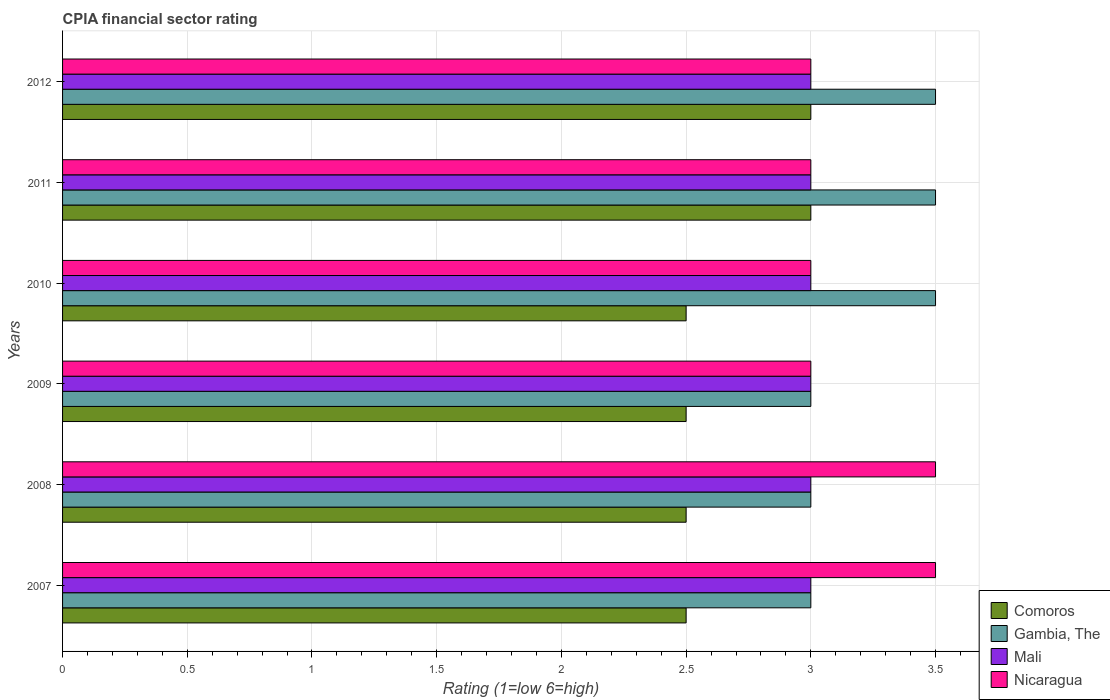How many different coloured bars are there?
Your response must be concise. 4. How many groups of bars are there?
Your answer should be very brief. 6. How many bars are there on the 1st tick from the top?
Provide a short and direct response. 4. In how many cases, is the number of bars for a given year not equal to the number of legend labels?
Provide a succinct answer. 0. Across all years, what is the maximum CPIA rating in Mali?
Ensure brevity in your answer.  3. Across all years, what is the minimum CPIA rating in Comoros?
Make the answer very short. 2.5. In which year was the CPIA rating in Gambia, The minimum?
Give a very brief answer. 2007. What is the total CPIA rating in Comoros in the graph?
Ensure brevity in your answer.  16. What is the difference between the CPIA rating in Nicaragua in 2009 and that in 2010?
Make the answer very short. 0. What is the difference between the CPIA rating in Comoros in 2009 and the CPIA rating in Nicaragua in 2008?
Your answer should be very brief. -1. What is the average CPIA rating in Gambia, The per year?
Offer a terse response. 3.25. What is the ratio of the CPIA rating in Mali in 2009 to that in 2012?
Keep it short and to the point. 1. Is the CPIA rating in Nicaragua in 2008 less than that in 2010?
Offer a very short reply. No. What is the difference between the highest and the lowest CPIA rating in Comoros?
Offer a very short reply. 0.5. In how many years, is the CPIA rating in Gambia, The greater than the average CPIA rating in Gambia, The taken over all years?
Ensure brevity in your answer.  3. What does the 2nd bar from the top in 2010 represents?
Make the answer very short. Mali. What does the 2nd bar from the bottom in 2007 represents?
Your response must be concise. Gambia, The. Is it the case that in every year, the sum of the CPIA rating in Gambia, The and CPIA rating in Mali is greater than the CPIA rating in Comoros?
Your answer should be compact. Yes. How many bars are there?
Ensure brevity in your answer.  24. How many years are there in the graph?
Provide a short and direct response. 6. How are the legend labels stacked?
Make the answer very short. Vertical. What is the title of the graph?
Make the answer very short. CPIA financial sector rating. What is the Rating (1=low 6=high) of Gambia, The in 2007?
Keep it short and to the point. 3. What is the Rating (1=low 6=high) of Comoros in 2008?
Your answer should be very brief. 2.5. What is the Rating (1=low 6=high) in Gambia, The in 2008?
Give a very brief answer. 3. What is the Rating (1=low 6=high) of Comoros in 2009?
Provide a short and direct response. 2.5. What is the Rating (1=low 6=high) in Comoros in 2010?
Your response must be concise. 2.5. What is the Rating (1=low 6=high) of Mali in 2010?
Ensure brevity in your answer.  3. What is the Rating (1=low 6=high) of Gambia, The in 2011?
Keep it short and to the point. 3.5. What is the Rating (1=low 6=high) in Mali in 2011?
Your answer should be very brief. 3. What is the Rating (1=low 6=high) in Nicaragua in 2011?
Offer a very short reply. 3. What is the Rating (1=low 6=high) in Gambia, The in 2012?
Give a very brief answer. 3.5. Across all years, what is the maximum Rating (1=low 6=high) of Mali?
Keep it short and to the point. 3. Across all years, what is the minimum Rating (1=low 6=high) of Comoros?
Make the answer very short. 2.5. Across all years, what is the minimum Rating (1=low 6=high) of Gambia, The?
Offer a very short reply. 3. What is the total Rating (1=low 6=high) of Comoros in the graph?
Make the answer very short. 16. What is the total Rating (1=low 6=high) in Mali in the graph?
Offer a very short reply. 18. What is the difference between the Rating (1=low 6=high) of Mali in 2007 and that in 2008?
Make the answer very short. 0. What is the difference between the Rating (1=low 6=high) in Comoros in 2007 and that in 2009?
Provide a short and direct response. 0. What is the difference between the Rating (1=low 6=high) in Gambia, The in 2007 and that in 2011?
Give a very brief answer. -0.5. What is the difference between the Rating (1=low 6=high) of Comoros in 2007 and that in 2012?
Keep it short and to the point. -0.5. What is the difference between the Rating (1=low 6=high) of Mali in 2007 and that in 2012?
Make the answer very short. 0. What is the difference between the Rating (1=low 6=high) of Nicaragua in 2007 and that in 2012?
Your answer should be compact. 0.5. What is the difference between the Rating (1=low 6=high) of Comoros in 2008 and that in 2009?
Provide a short and direct response. 0. What is the difference between the Rating (1=low 6=high) of Mali in 2008 and that in 2010?
Offer a very short reply. 0. What is the difference between the Rating (1=low 6=high) of Nicaragua in 2008 and that in 2010?
Your answer should be very brief. 0.5. What is the difference between the Rating (1=low 6=high) of Nicaragua in 2008 and that in 2011?
Offer a very short reply. 0.5. What is the difference between the Rating (1=low 6=high) in Comoros in 2008 and that in 2012?
Provide a succinct answer. -0.5. What is the difference between the Rating (1=low 6=high) of Mali in 2008 and that in 2012?
Offer a very short reply. 0. What is the difference between the Rating (1=low 6=high) in Nicaragua in 2008 and that in 2012?
Your answer should be very brief. 0.5. What is the difference between the Rating (1=low 6=high) of Nicaragua in 2009 and that in 2010?
Offer a very short reply. 0. What is the difference between the Rating (1=low 6=high) in Mali in 2009 and that in 2012?
Your answer should be very brief. 0. What is the difference between the Rating (1=low 6=high) of Nicaragua in 2009 and that in 2012?
Offer a very short reply. 0. What is the difference between the Rating (1=low 6=high) of Comoros in 2010 and that in 2011?
Your response must be concise. -0.5. What is the difference between the Rating (1=low 6=high) of Comoros in 2010 and that in 2012?
Ensure brevity in your answer.  -0.5. What is the difference between the Rating (1=low 6=high) in Mali in 2010 and that in 2012?
Ensure brevity in your answer.  0. What is the difference between the Rating (1=low 6=high) of Nicaragua in 2010 and that in 2012?
Provide a short and direct response. 0. What is the difference between the Rating (1=low 6=high) of Gambia, The in 2011 and that in 2012?
Ensure brevity in your answer.  0. What is the difference between the Rating (1=low 6=high) in Mali in 2011 and that in 2012?
Give a very brief answer. 0. What is the difference between the Rating (1=low 6=high) of Comoros in 2007 and the Rating (1=low 6=high) of Mali in 2008?
Your answer should be very brief. -0.5. What is the difference between the Rating (1=low 6=high) in Gambia, The in 2007 and the Rating (1=low 6=high) in Mali in 2008?
Your answer should be very brief. 0. What is the difference between the Rating (1=low 6=high) of Gambia, The in 2007 and the Rating (1=low 6=high) of Nicaragua in 2008?
Your answer should be very brief. -0.5. What is the difference between the Rating (1=low 6=high) in Comoros in 2007 and the Rating (1=low 6=high) in Gambia, The in 2009?
Ensure brevity in your answer.  -0.5. What is the difference between the Rating (1=low 6=high) of Comoros in 2007 and the Rating (1=low 6=high) of Mali in 2009?
Offer a terse response. -0.5. What is the difference between the Rating (1=low 6=high) of Gambia, The in 2007 and the Rating (1=low 6=high) of Mali in 2010?
Your response must be concise. 0. What is the difference between the Rating (1=low 6=high) in Comoros in 2007 and the Rating (1=low 6=high) in Nicaragua in 2011?
Keep it short and to the point. -0.5. What is the difference between the Rating (1=low 6=high) of Gambia, The in 2007 and the Rating (1=low 6=high) of Nicaragua in 2011?
Your answer should be very brief. 0. What is the difference between the Rating (1=low 6=high) in Comoros in 2007 and the Rating (1=low 6=high) in Gambia, The in 2012?
Your answer should be compact. -1. What is the difference between the Rating (1=low 6=high) of Comoros in 2007 and the Rating (1=low 6=high) of Mali in 2012?
Provide a succinct answer. -0.5. What is the difference between the Rating (1=low 6=high) of Mali in 2007 and the Rating (1=low 6=high) of Nicaragua in 2012?
Provide a short and direct response. 0. What is the difference between the Rating (1=low 6=high) of Gambia, The in 2008 and the Rating (1=low 6=high) of Mali in 2009?
Make the answer very short. 0. What is the difference between the Rating (1=low 6=high) of Gambia, The in 2008 and the Rating (1=low 6=high) of Nicaragua in 2009?
Give a very brief answer. 0. What is the difference between the Rating (1=low 6=high) in Comoros in 2008 and the Rating (1=low 6=high) in Gambia, The in 2010?
Your response must be concise. -1. What is the difference between the Rating (1=low 6=high) of Comoros in 2008 and the Rating (1=low 6=high) of Mali in 2010?
Your response must be concise. -0.5. What is the difference between the Rating (1=low 6=high) in Gambia, The in 2008 and the Rating (1=low 6=high) in Nicaragua in 2010?
Your response must be concise. 0. What is the difference between the Rating (1=low 6=high) of Mali in 2008 and the Rating (1=low 6=high) of Nicaragua in 2010?
Offer a terse response. 0. What is the difference between the Rating (1=low 6=high) in Comoros in 2008 and the Rating (1=low 6=high) in Mali in 2011?
Give a very brief answer. -0.5. What is the difference between the Rating (1=low 6=high) in Comoros in 2008 and the Rating (1=low 6=high) in Nicaragua in 2011?
Give a very brief answer. -0.5. What is the difference between the Rating (1=low 6=high) of Comoros in 2008 and the Rating (1=low 6=high) of Gambia, The in 2012?
Provide a succinct answer. -1. What is the difference between the Rating (1=low 6=high) in Mali in 2008 and the Rating (1=low 6=high) in Nicaragua in 2012?
Keep it short and to the point. 0. What is the difference between the Rating (1=low 6=high) in Comoros in 2009 and the Rating (1=low 6=high) in Gambia, The in 2010?
Provide a succinct answer. -1. What is the difference between the Rating (1=low 6=high) in Comoros in 2009 and the Rating (1=low 6=high) in Mali in 2010?
Ensure brevity in your answer.  -0.5. What is the difference between the Rating (1=low 6=high) in Comoros in 2009 and the Rating (1=low 6=high) in Nicaragua in 2010?
Keep it short and to the point. -0.5. What is the difference between the Rating (1=low 6=high) in Gambia, The in 2009 and the Rating (1=low 6=high) in Mali in 2010?
Provide a succinct answer. 0. What is the difference between the Rating (1=low 6=high) in Mali in 2009 and the Rating (1=low 6=high) in Nicaragua in 2010?
Your answer should be compact. 0. What is the difference between the Rating (1=low 6=high) of Comoros in 2009 and the Rating (1=low 6=high) of Mali in 2011?
Make the answer very short. -0.5. What is the difference between the Rating (1=low 6=high) of Gambia, The in 2009 and the Rating (1=low 6=high) of Mali in 2011?
Provide a succinct answer. 0. What is the difference between the Rating (1=low 6=high) of Comoros in 2009 and the Rating (1=low 6=high) of Gambia, The in 2012?
Ensure brevity in your answer.  -1. What is the difference between the Rating (1=low 6=high) of Comoros in 2009 and the Rating (1=low 6=high) of Nicaragua in 2012?
Offer a very short reply. -0.5. What is the difference between the Rating (1=low 6=high) of Gambia, The in 2009 and the Rating (1=low 6=high) of Mali in 2012?
Keep it short and to the point. 0. What is the difference between the Rating (1=low 6=high) of Mali in 2009 and the Rating (1=low 6=high) of Nicaragua in 2012?
Provide a short and direct response. 0. What is the difference between the Rating (1=low 6=high) in Comoros in 2010 and the Rating (1=low 6=high) in Gambia, The in 2011?
Keep it short and to the point. -1. What is the difference between the Rating (1=low 6=high) of Comoros in 2010 and the Rating (1=low 6=high) of Mali in 2011?
Provide a short and direct response. -0.5. What is the difference between the Rating (1=low 6=high) of Comoros in 2010 and the Rating (1=low 6=high) of Nicaragua in 2011?
Give a very brief answer. -0.5. What is the difference between the Rating (1=low 6=high) in Gambia, The in 2010 and the Rating (1=low 6=high) in Mali in 2011?
Your answer should be very brief. 0.5. What is the difference between the Rating (1=low 6=high) in Gambia, The in 2010 and the Rating (1=low 6=high) in Nicaragua in 2011?
Provide a succinct answer. 0.5. What is the difference between the Rating (1=low 6=high) in Comoros in 2010 and the Rating (1=low 6=high) in Mali in 2012?
Your answer should be compact. -0.5. What is the difference between the Rating (1=low 6=high) of Comoros in 2010 and the Rating (1=low 6=high) of Nicaragua in 2012?
Keep it short and to the point. -0.5. What is the difference between the Rating (1=low 6=high) of Comoros in 2011 and the Rating (1=low 6=high) of Mali in 2012?
Make the answer very short. 0. What is the average Rating (1=low 6=high) in Comoros per year?
Keep it short and to the point. 2.67. What is the average Rating (1=low 6=high) in Gambia, The per year?
Provide a short and direct response. 3.25. What is the average Rating (1=low 6=high) of Mali per year?
Give a very brief answer. 3. What is the average Rating (1=low 6=high) in Nicaragua per year?
Give a very brief answer. 3.17. In the year 2007, what is the difference between the Rating (1=low 6=high) in Comoros and Rating (1=low 6=high) in Nicaragua?
Your answer should be compact. -1. In the year 2007, what is the difference between the Rating (1=low 6=high) in Mali and Rating (1=low 6=high) in Nicaragua?
Your answer should be compact. -0.5. In the year 2008, what is the difference between the Rating (1=low 6=high) of Comoros and Rating (1=low 6=high) of Gambia, The?
Provide a succinct answer. -0.5. In the year 2008, what is the difference between the Rating (1=low 6=high) in Gambia, The and Rating (1=low 6=high) in Mali?
Your answer should be compact. 0. In the year 2009, what is the difference between the Rating (1=low 6=high) in Comoros and Rating (1=low 6=high) in Mali?
Provide a short and direct response. -0.5. In the year 2009, what is the difference between the Rating (1=low 6=high) in Comoros and Rating (1=low 6=high) in Nicaragua?
Make the answer very short. -0.5. In the year 2009, what is the difference between the Rating (1=low 6=high) of Gambia, The and Rating (1=low 6=high) of Mali?
Provide a short and direct response. 0. In the year 2009, what is the difference between the Rating (1=low 6=high) of Mali and Rating (1=low 6=high) of Nicaragua?
Keep it short and to the point. 0. In the year 2010, what is the difference between the Rating (1=low 6=high) of Comoros and Rating (1=low 6=high) of Mali?
Offer a very short reply. -0.5. In the year 2010, what is the difference between the Rating (1=low 6=high) of Comoros and Rating (1=low 6=high) of Nicaragua?
Your answer should be compact. -0.5. In the year 2010, what is the difference between the Rating (1=low 6=high) of Gambia, The and Rating (1=low 6=high) of Nicaragua?
Ensure brevity in your answer.  0.5. In the year 2011, what is the difference between the Rating (1=low 6=high) in Gambia, The and Rating (1=low 6=high) in Mali?
Make the answer very short. 0.5. In the year 2011, what is the difference between the Rating (1=low 6=high) of Gambia, The and Rating (1=low 6=high) of Nicaragua?
Your answer should be compact. 0.5. In the year 2011, what is the difference between the Rating (1=low 6=high) in Mali and Rating (1=low 6=high) in Nicaragua?
Keep it short and to the point. 0. In the year 2012, what is the difference between the Rating (1=low 6=high) of Comoros and Rating (1=low 6=high) of Gambia, The?
Offer a very short reply. -0.5. In the year 2012, what is the difference between the Rating (1=low 6=high) of Comoros and Rating (1=low 6=high) of Mali?
Offer a terse response. 0. What is the ratio of the Rating (1=low 6=high) of Comoros in 2007 to that in 2008?
Make the answer very short. 1. What is the ratio of the Rating (1=low 6=high) of Mali in 2007 to that in 2008?
Provide a succinct answer. 1. What is the ratio of the Rating (1=low 6=high) of Mali in 2007 to that in 2010?
Offer a very short reply. 1. What is the ratio of the Rating (1=low 6=high) in Nicaragua in 2007 to that in 2010?
Offer a very short reply. 1.17. What is the ratio of the Rating (1=low 6=high) of Gambia, The in 2007 to that in 2011?
Keep it short and to the point. 0.86. What is the ratio of the Rating (1=low 6=high) of Nicaragua in 2007 to that in 2011?
Your response must be concise. 1.17. What is the ratio of the Rating (1=low 6=high) of Nicaragua in 2007 to that in 2012?
Provide a succinct answer. 1.17. What is the ratio of the Rating (1=low 6=high) of Gambia, The in 2008 to that in 2009?
Your answer should be compact. 1. What is the ratio of the Rating (1=low 6=high) in Mali in 2008 to that in 2009?
Your response must be concise. 1. What is the ratio of the Rating (1=low 6=high) in Nicaragua in 2008 to that in 2011?
Ensure brevity in your answer.  1.17. What is the ratio of the Rating (1=low 6=high) in Comoros in 2008 to that in 2012?
Offer a terse response. 0.83. What is the ratio of the Rating (1=low 6=high) in Nicaragua in 2008 to that in 2012?
Ensure brevity in your answer.  1.17. What is the ratio of the Rating (1=low 6=high) of Gambia, The in 2009 to that in 2010?
Make the answer very short. 0.86. What is the ratio of the Rating (1=low 6=high) of Mali in 2009 to that in 2010?
Keep it short and to the point. 1. What is the ratio of the Rating (1=low 6=high) in Comoros in 2009 to that in 2011?
Your answer should be compact. 0.83. What is the ratio of the Rating (1=low 6=high) in Comoros in 2009 to that in 2012?
Your response must be concise. 0.83. What is the ratio of the Rating (1=low 6=high) in Gambia, The in 2009 to that in 2012?
Make the answer very short. 0.86. What is the ratio of the Rating (1=low 6=high) in Mali in 2009 to that in 2012?
Offer a terse response. 1. What is the ratio of the Rating (1=low 6=high) of Nicaragua in 2009 to that in 2012?
Give a very brief answer. 1. What is the ratio of the Rating (1=low 6=high) of Comoros in 2010 to that in 2011?
Offer a terse response. 0.83. What is the ratio of the Rating (1=low 6=high) of Gambia, The in 2010 to that in 2011?
Provide a short and direct response. 1. What is the ratio of the Rating (1=low 6=high) of Comoros in 2010 to that in 2012?
Provide a succinct answer. 0.83. What is the ratio of the Rating (1=low 6=high) of Nicaragua in 2010 to that in 2012?
Keep it short and to the point. 1. What is the ratio of the Rating (1=low 6=high) of Comoros in 2011 to that in 2012?
Ensure brevity in your answer.  1. What is the ratio of the Rating (1=low 6=high) in Gambia, The in 2011 to that in 2012?
Keep it short and to the point. 1. What is the ratio of the Rating (1=low 6=high) in Nicaragua in 2011 to that in 2012?
Your response must be concise. 1. What is the difference between the highest and the second highest Rating (1=low 6=high) of Comoros?
Give a very brief answer. 0. What is the difference between the highest and the second highest Rating (1=low 6=high) of Mali?
Offer a terse response. 0. What is the difference between the highest and the lowest Rating (1=low 6=high) in Gambia, The?
Keep it short and to the point. 0.5. What is the difference between the highest and the lowest Rating (1=low 6=high) in Nicaragua?
Provide a succinct answer. 0.5. 